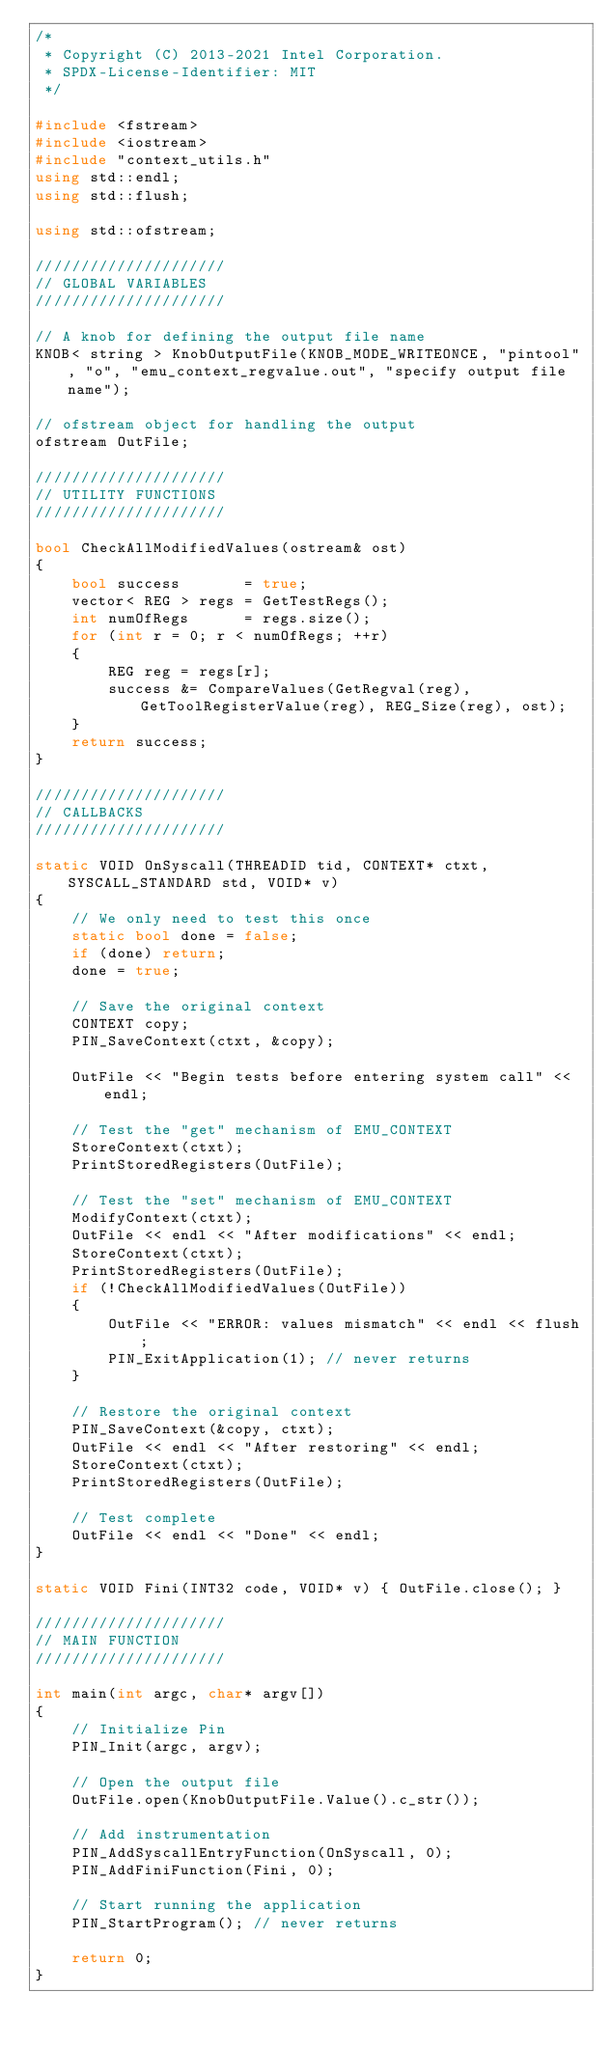Convert code to text. <code><loc_0><loc_0><loc_500><loc_500><_C++_>/*
 * Copyright (C) 2013-2021 Intel Corporation.
 * SPDX-License-Identifier: MIT
 */

#include <fstream>
#include <iostream>
#include "context_utils.h"
using std::endl;
using std::flush;

using std::ofstream;

/////////////////////
// GLOBAL VARIABLES
/////////////////////

// A knob for defining the output file name
KNOB< string > KnobOutputFile(KNOB_MODE_WRITEONCE, "pintool", "o", "emu_context_regvalue.out", "specify output file name");

// ofstream object for handling the output
ofstream OutFile;

/////////////////////
// UTILITY FUNCTIONS
/////////////////////

bool CheckAllModifiedValues(ostream& ost)
{
    bool success       = true;
    vector< REG > regs = GetTestRegs();
    int numOfRegs      = regs.size();
    for (int r = 0; r < numOfRegs; ++r)
    {
        REG reg = regs[r];
        success &= CompareValues(GetRegval(reg), GetToolRegisterValue(reg), REG_Size(reg), ost);
    }
    return success;
}

/////////////////////
// CALLBACKS
/////////////////////

static VOID OnSyscall(THREADID tid, CONTEXT* ctxt, SYSCALL_STANDARD std, VOID* v)
{
    // We only need to test this once
    static bool done = false;
    if (done) return;
    done = true;

    // Save the original context
    CONTEXT copy;
    PIN_SaveContext(ctxt, &copy);

    OutFile << "Begin tests before entering system call" << endl;

    // Test the "get" mechanism of EMU_CONTEXT
    StoreContext(ctxt);
    PrintStoredRegisters(OutFile);

    // Test the "set" mechanism of EMU_CONTEXT
    ModifyContext(ctxt);
    OutFile << endl << "After modifications" << endl;
    StoreContext(ctxt);
    PrintStoredRegisters(OutFile);
    if (!CheckAllModifiedValues(OutFile))
    {
        OutFile << "ERROR: values mismatch" << endl << flush;
        PIN_ExitApplication(1); // never returns
    }

    // Restore the original context
    PIN_SaveContext(&copy, ctxt);
    OutFile << endl << "After restoring" << endl;
    StoreContext(ctxt);
    PrintStoredRegisters(OutFile);

    // Test complete
    OutFile << endl << "Done" << endl;
}

static VOID Fini(INT32 code, VOID* v) { OutFile.close(); }

/////////////////////
// MAIN FUNCTION
/////////////////////

int main(int argc, char* argv[])
{
    // Initialize Pin
    PIN_Init(argc, argv);

    // Open the output file
    OutFile.open(KnobOutputFile.Value().c_str());

    // Add instrumentation
    PIN_AddSyscallEntryFunction(OnSyscall, 0);
    PIN_AddFiniFunction(Fini, 0);

    // Start running the application
    PIN_StartProgram(); // never returns

    return 0;
}
</code> 